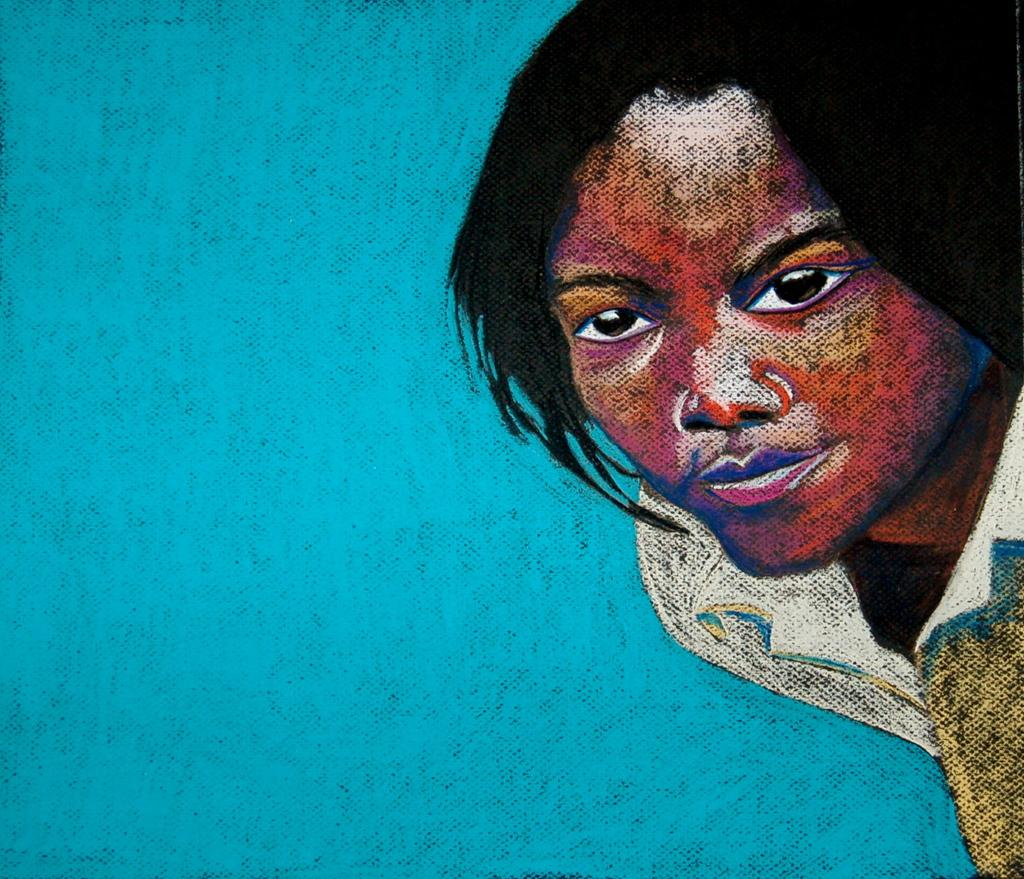What type of image is being described? The image is an animation. Can you describe any characters or figures in the animation? There is a woman on the right side of the animation. What color is the woman's tongue in the animation? There is no information about the woman's tongue in the provided facts, so we cannot determine its color. 